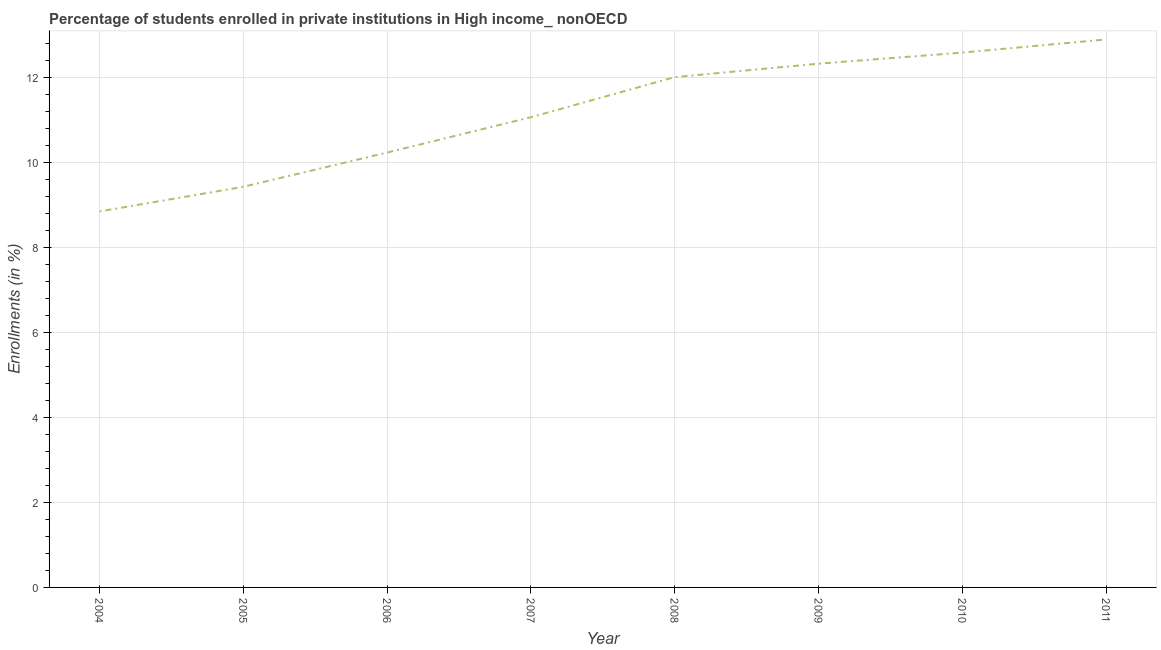What is the enrollments in private institutions in 2009?
Your answer should be very brief. 12.32. Across all years, what is the maximum enrollments in private institutions?
Make the answer very short. 12.89. Across all years, what is the minimum enrollments in private institutions?
Your answer should be compact. 8.84. In which year was the enrollments in private institutions maximum?
Ensure brevity in your answer.  2011. What is the sum of the enrollments in private institutions?
Make the answer very short. 89.36. What is the difference between the enrollments in private institutions in 2009 and 2011?
Your answer should be very brief. -0.57. What is the average enrollments in private institutions per year?
Offer a terse response. 11.17. What is the median enrollments in private institutions?
Provide a short and direct response. 11.53. In how many years, is the enrollments in private institutions greater than 7.2 %?
Offer a very short reply. 8. What is the ratio of the enrollments in private institutions in 2006 to that in 2011?
Offer a terse response. 0.79. Is the enrollments in private institutions in 2005 less than that in 2009?
Your answer should be very brief. Yes. Is the difference between the enrollments in private institutions in 2005 and 2008 greater than the difference between any two years?
Your response must be concise. No. What is the difference between the highest and the second highest enrollments in private institutions?
Make the answer very short. 0.31. What is the difference between the highest and the lowest enrollments in private institutions?
Your answer should be compact. 4.05. How many lines are there?
Provide a short and direct response. 1. Does the graph contain any zero values?
Your response must be concise. No. What is the title of the graph?
Make the answer very short. Percentage of students enrolled in private institutions in High income_ nonOECD. What is the label or title of the Y-axis?
Your answer should be very brief. Enrollments (in %). What is the Enrollments (in %) in 2004?
Your answer should be compact. 8.84. What is the Enrollments (in %) of 2005?
Your response must be concise. 9.42. What is the Enrollments (in %) of 2006?
Offer a very short reply. 10.23. What is the Enrollments (in %) of 2007?
Make the answer very short. 11.06. What is the Enrollments (in %) in 2008?
Your response must be concise. 12. What is the Enrollments (in %) in 2009?
Provide a short and direct response. 12.32. What is the Enrollments (in %) of 2010?
Keep it short and to the point. 12.58. What is the Enrollments (in %) in 2011?
Your answer should be very brief. 12.89. What is the difference between the Enrollments (in %) in 2004 and 2005?
Keep it short and to the point. -0.58. What is the difference between the Enrollments (in %) in 2004 and 2006?
Make the answer very short. -1.39. What is the difference between the Enrollments (in %) in 2004 and 2007?
Provide a succinct answer. -2.22. What is the difference between the Enrollments (in %) in 2004 and 2008?
Your answer should be very brief. -3.16. What is the difference between the Enrollments (in %) in 2004 and 2009?
Ensure brevity in your answer.  -3.48. What is the difference between the Enrollments (in %) in 2004 and 2010?
Offer a very short reply. -3.74. What is the difference between the Enrollments (in %) in 2004 and 2011?
Provide a short and direct response. -4.05. What is the difference between the Enrollments (in %) in 2005 and 2006?
Offer a very short reply. -0.81. What is the difference between the Enrollments (in %) in 2005 and 2007?
Make the answer very short. -1.64. What is the difference between the Enrollments (in %) in 2005 and 2008?
Make the answer very short. -2.58. What is the difference between the Enrollments (in %) in 2005 and 2009?
Offer a very short reply. -2.9. What is the difference between the Enrollments (in %) in 2005 and 2010?
Provide a short and direct response. -3.16. What is the difference between the Enrollments (in %) in 2005 and 2011?
Provide a succinct answer. -3.47. What is the difference between the Enrollments (in %) in 2006 and 2007?
Give a very brief answer. -0.83. What is the difference between the Enrollments (in %) in 2006 and 2008?
Give a very brief answer. -1.78. What is the difference between the Enrollments (in %) in 2006 and 2009?
Your response must be concise. -2.09. What is the difference between the Enrollments (in %) in 2006 and 2010?
Give a very brief answer. -2.35. What is the difference between the Enrollments (in %) in 2006 and 2011?
Provide a short and direct response. -2.66. What is the difference between the Enrollments (in %) in 2007 and 2008?
Your answer should be very brief. -0.94. What is the difference between the Enrollments (in %) in 2007 and 2009?
Keep it short and to the point. -1.26. What is the difference between the Enrollments (in %) in 2007 and 2010?
Give a very brief answer. -1.52. What is the difference between the Enrollments (in %) in 2007 and 2011?
Provide a short and direct response. -1.83. What is the difference between the Enrollments (in %) in 2008 and 2009?
Keep it short and to the point. -0.32. What is the difference between the Enrollments (in %) in 2008 and 2010?
Ensure brevity in your answer.  -0.58. What is the difference between the Enrollments (in %) in 2008 and 2011?
Provide a succinct answer. -0.89. What is the difference between the Enrollments (in %) in 2009 and 2010?
Ensure brevity in your answer.  -0.26. What is the difference between the Enrollments (in %) in 2009 and 2011?
Ensure brevity in your answer.  -0.57. What is the difference between the Enrollments (in %) in 2010 and 2011?
Offer a terse response. -0.31. What is the ratio of the Enrollments (in %) in 2004 to that in 2005?
Your answer should be compact. 0.94. What is the ratio of the Enrollments (in %) in 2004 to that in 2006?
Provide a short and direct response. 0.86. What is the ratio of the Enrollments (in %) in 2004 to that in 2008?
Offer a terse response. 0.74. What is the ratio of the Enrollments (in %) in 2004 to that in 2009?
Provide a succinct answer. 0.72. What is the ratio of the Enrollments (in %) in 2004 to that in 2010?
Offer a terse response. 0.7. What is the ratio of the Enrollments (in %) in 2004 to that in 2011?
Your answer should be very brief. 0.69. What is the ratio of the Enrollments (in %) in 2005 to that in 2006?
Your response must be concise. 0.92. What is the ratio of the Enrollments (in %) in 2005 to that in 2007?
Provide a short and direct response. 0.85. What is the ratio of the Enrollments (in %) in 2005 to that in 2008?
Your response must be concise. 0.79. What is the ratio of the Enrollments (in %) in 2005 to that in 2009?
Provide a short and direct response. 0.77. What is the ratio of the Enrollments (in %) in 2005 to that in 2010?
Make the answer very short. 0.75. What is the ratio of the Enrollments (in %) in 2005 to that in 2011?
Make the answer very short. 0.73. What is the ratio of the Enrollments (in %) in 2006 to that in 2007?
Provide a succinct answer. 0.93. What is the ratio of the Enrollments (in %) in 2006 to that in 2008?
Give a very brief answer. 0.85. What is the ratio of the Enrollments (in %) in 2006 to that in 2009?
Your answer should be very brief. 0.83. What is the ratio of the Enrollments (in %) in 2006 to that in 2010?
Provide a short and direct response. 0.81. What is the ratio of the Enrollments (in %) in 2006 to that in 2011?
Your response must be concise. 0.79. What is the ratio of the Enrollments (in %) in 2007 to that in 2008?
Provide a short and direct response. 0.92. What is the ratio of the Enrollments (in %) in 2007 to that in 2009?
Keep it short and to the point. 0.9. What is the ratio of the Enrollments (in %) in 2007 to that in 2010?
Ensure brevity in your answer.  0.88. What is the ratio of the Enrollments (in %) in 2007 to that in 2011?
Give a very brief answer. 0.86. What is the ratio of the Enrollments (in %) in 2008 to that in 2010?
Give a very brief answer. 0.95. What is the ratio of the Enrollments (in %) in 2009 to that in 2010?
Offer a terse response. 0.98. What is the ratio of the Enrollments (in %) in 2009 to that in 2011?
Provide a short and direct response. 0.96. 